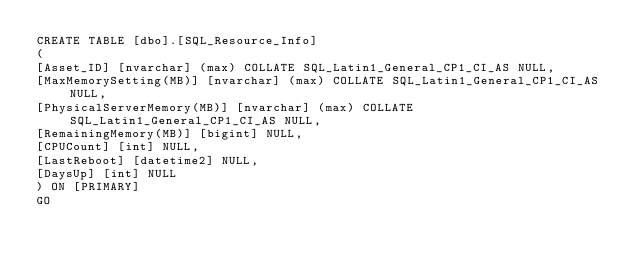<code> <loc_0><loc_0><loc_500><loc_500><_SQL_>CREATE TABLE [dbo].[SQL_Resource_Info]
(
[Asset_ID] [nvarchar] (max) COLLATE SQL_Latin1_General_CP1_CI_AS NULL,
[MaxMemorySetting(MB)] [nvarchar] (max) COLLATE SQL_Latin1_General_CP1_CI_AS NULL,
[PhysicalServerMemory(MB)] [nvarchar] (max) COLLATE SQL_Latin1_General_CP1_CI_AS NULL,
[RemainingMemory(MB)] [bigint] NULL,
[CPUCount] [int] NULL,
[LastReboot] [datetime2] NULL,
[DaysUp] [int] NULL
) ON [PRIMARY]
GO
</code> 